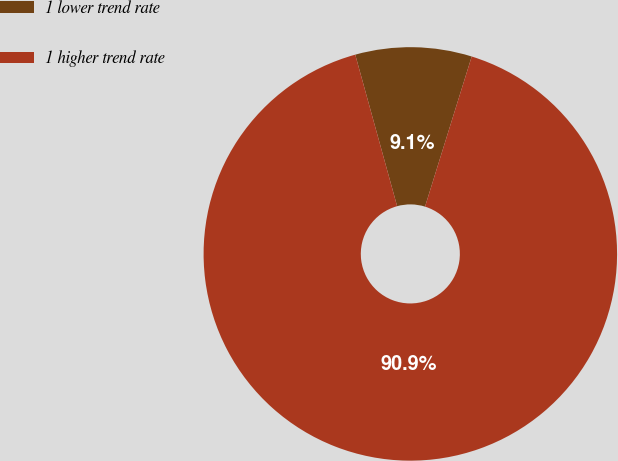Convert chart to OTSL. <chart><loc_0><loc_0><loc_500><loc_500><pie_chart><fcel>1 lower trend rate<fcel>1 higher trend rate<nl><fcel>9.09%<fcel>90.91%<nl></chart> 